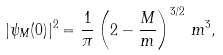Convert formula to latex. <formula><loc_0><loc_0><loc_500><loc_500>| \psi _ { M } ( 0 ) | ^ { 2 } = \frac { 1 } { \pi } \left ( 2 - \frac { M } { m } \right ) ^ { 3 / 2 } \, m ^ { 3 } ,</formula> 